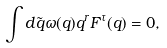<formula> <loc_0><loc_0><loc_500><loc_500>\int d \tilde { q } \omega ( q ) q ^ { r } F ^ { \tau } ( q ) = 0 ,</formula> 